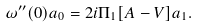<formula> <loc_0><loc_0><loc_500><loc_500>\omega ^ { \prime \prime } ( 0 ) a _ { 0 } = 2 i \Pi _ { 1 } [ A - V ] a _ { 1 } .</formula> 